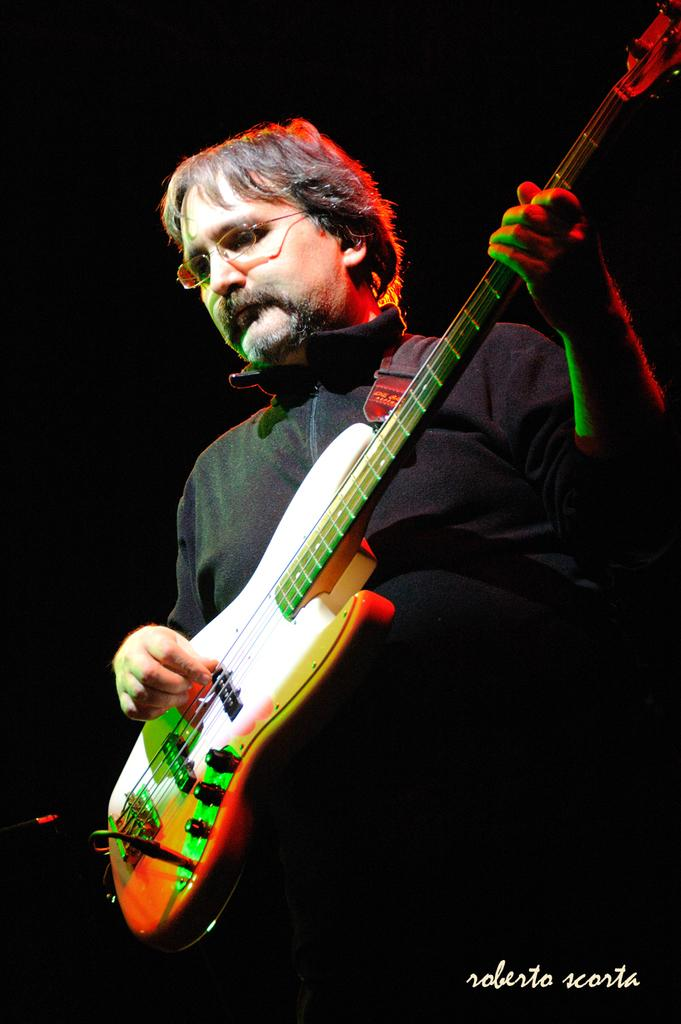What is the main subject of the image? The main subject of the image is a man. What is the man doing in the image? The man is playing a guitar in the image. What type of potato can be seen growing in the image? There is no potato present in the image; it features a man playing a guitar. How many knots are visible in the image? There are no knots visible in the image; it features a man playing a guitar. 